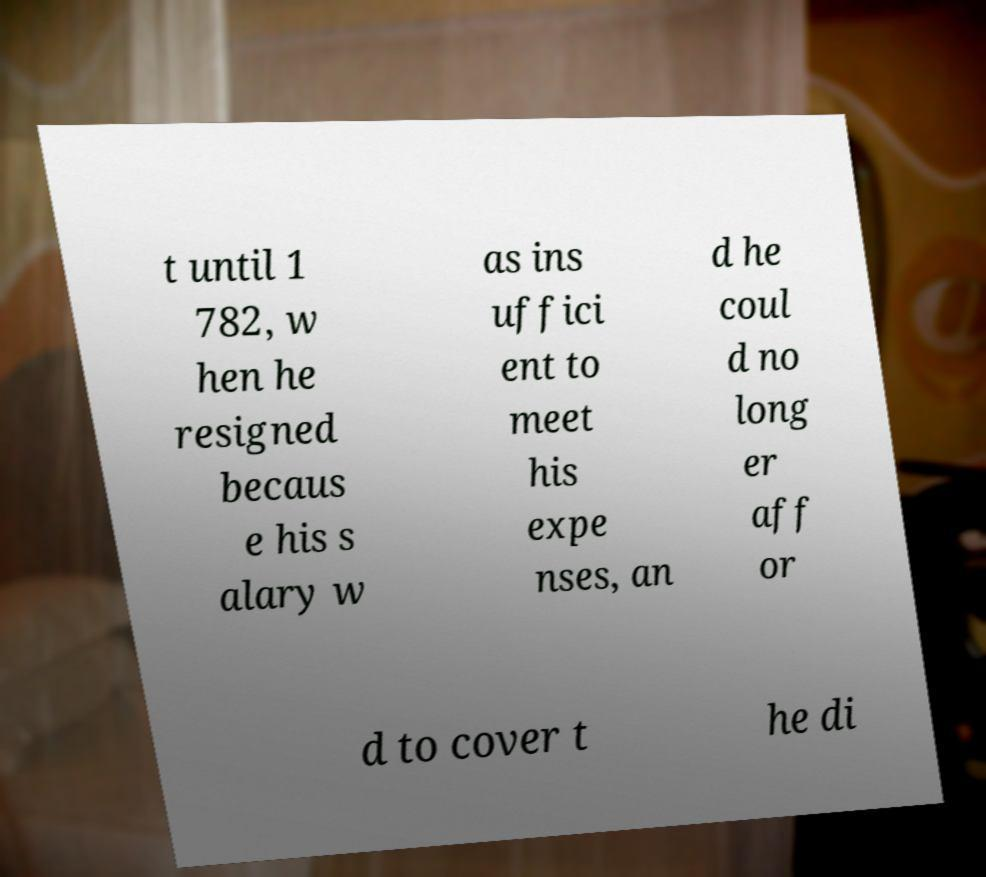For documentation purposes, I need the text within this image transcribed. Could you provide that? t until 1 782, w hen he resigned becaus e his s alary w as ins uffici ent to meet his expe nses, an d he coul d no long er aff or d to cover t he di 